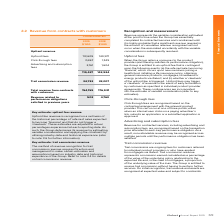According to Iselect's financial document, What are trial commissions? ongoing fees for customers referred to individual product providers or who have applied for mortgages via iSelect. The document states: "Trail commissions are ongoing fees for customers referred to individual product providers or who have applied for mortgages via iSelect. Trail commiss..." Also, How does the Group determine its revenue? by estimating variable consideration and applying the constraint by utilising industry data and historical experience. The document states: "g date. As such, the Group determines its revenue by estimating variable consideration and applying the constraint by utilising industry data and hist..." Also, How are click-through fees recognised? based on the contractual arrangement with the relevant product provider. The document states: "Click-through fees are recognised based on the contractual arrangement with the relevant product provider. This can occur at one of three points; eith..." Also, can you calculate: What is the percentage change in upfront fees from 2018 to 2019? To answer this question, I need to perform calculations using the financial data. The calculation is: (113,609-140,971)/140,971, which equals -19.41 (percentage). This is based on the information: "Upfront fees 113,609 140,971 Upfront fees 113,609 140,971..." The key data points involved are: 113,609, 140,971. Also, can you calculate: What is the percentage change in click-through fees from 2018 to 2019? To answer this question, I need to perform calculations using the financial data. The calculation is: (3,657-1,349)/1,349, which equals 171.09 (percentage). This is based on the information: "Click-through fees 3,657 1,349 Click-through fees 3,657 1,349..." The key data points involved are: 1,349, 3,657. Also, can you calculate: What is the percentage change in the total upfront revenue from 2018 to 2019? To answer this question, I need to perform calculations using the financial data. The calculation is: (119,427-143,924)/143,924, which equals -17.02 (percentage). This is based on the information: "119,427 143,924 119,427 143,924..." The key data points involved are: 119,427, 143,924. 